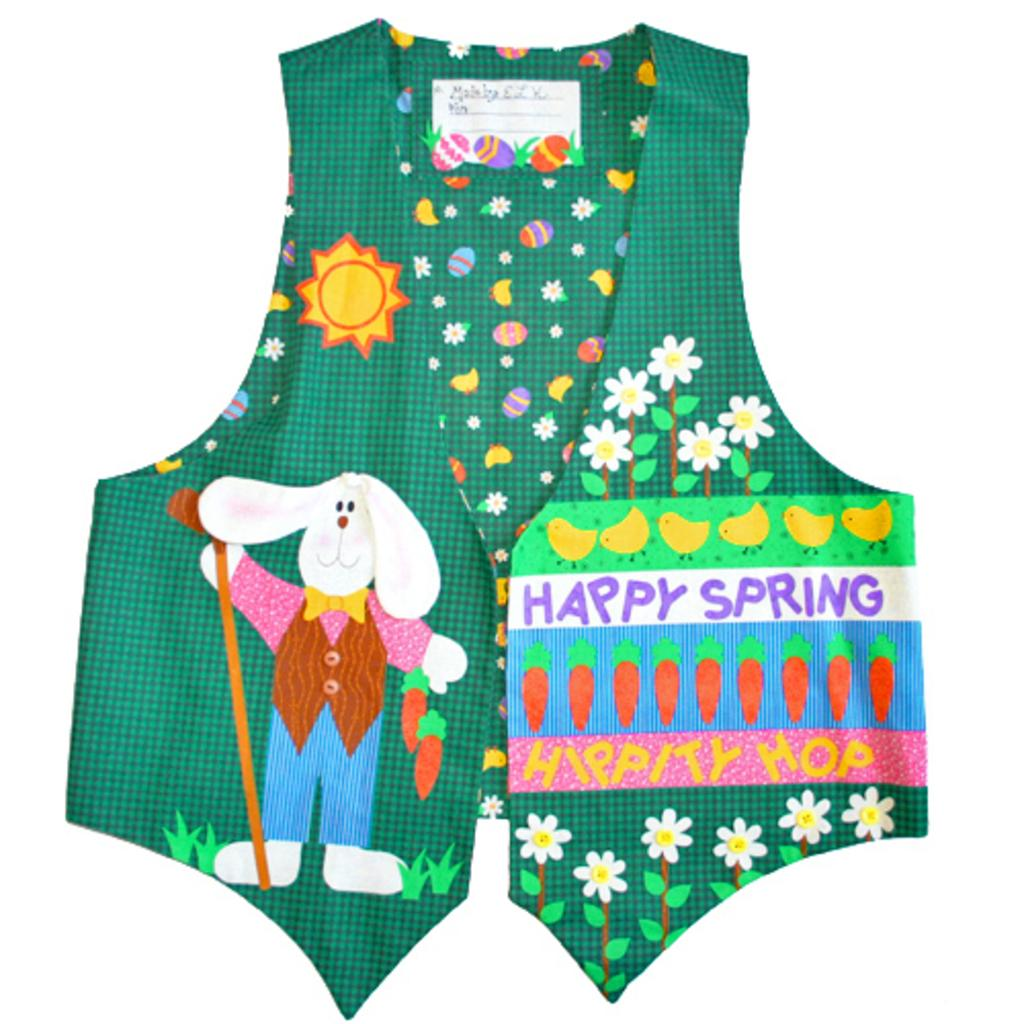What type of clothing is present in the image? The image contains a dress. What color is the dress? The dress is green. Are there any patterns or designs on the dress? Yes, the dress has text and flowers on it. What type of amusement can be seen in the image? There is no amusement present in the image; it features a green dress with text and flowers. How many pizzas are visible in the image? There are no pizzas present in the image. 